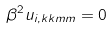Convert formula to latex. <formula><loc_0><loc_0><loc_500><loc_500>\beta ^ { 2 } u _ { i , k k m m } = 0</formula> 